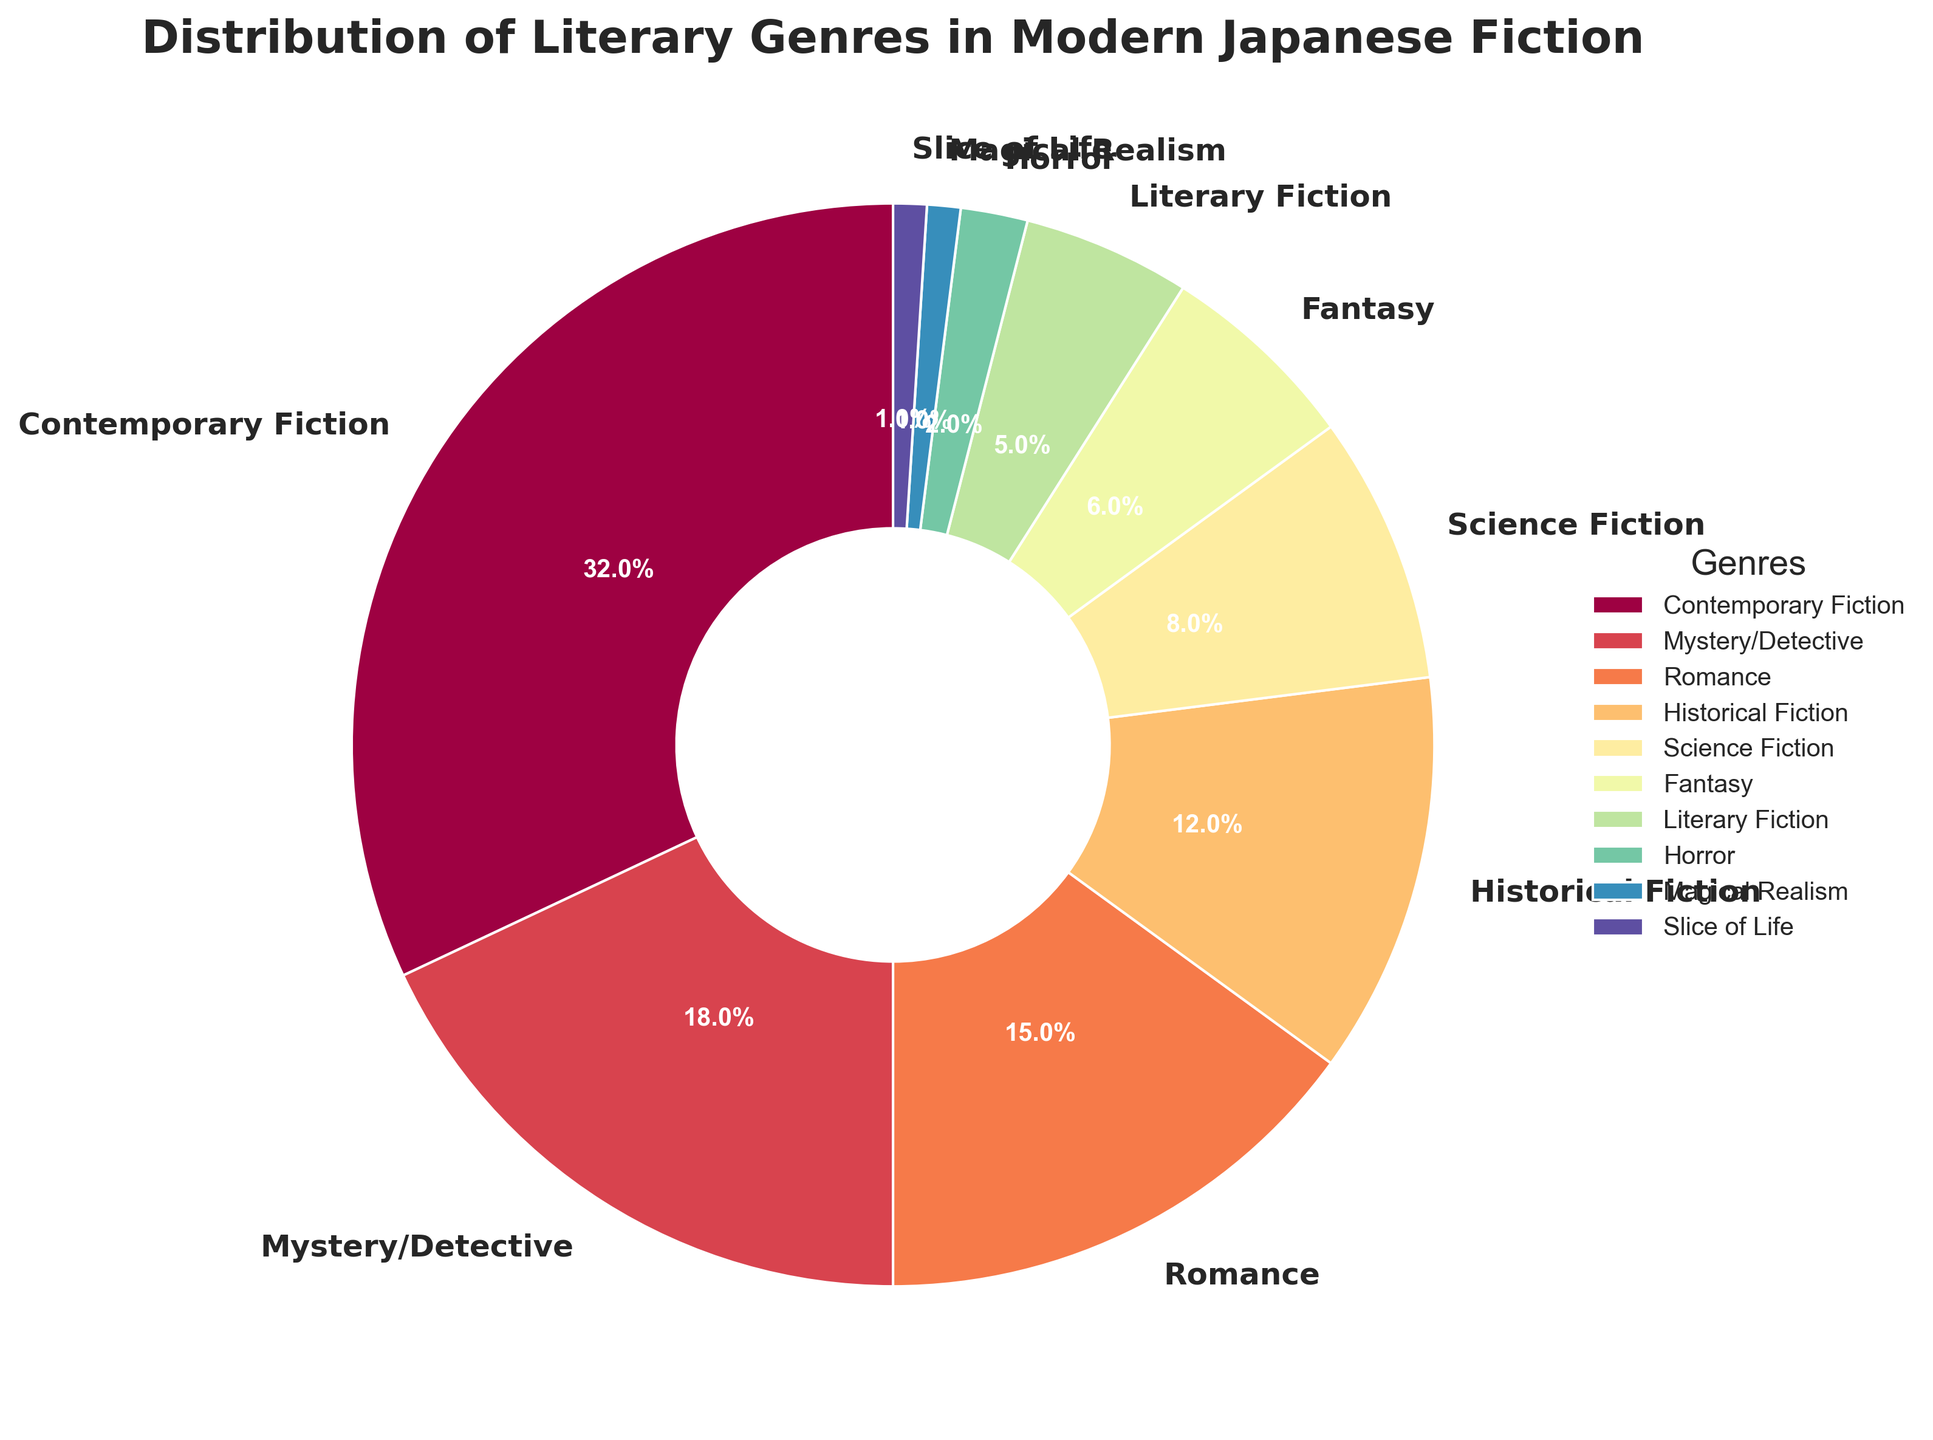Which genre has the highest percentage of distribution in modern Japanese fiction? From the pie chart, Contemporary Fiction occupies the largest segment, which corresponds to 32%.
Answer: Contemporary Fiction Which two genres combined represent less than 10% of the total distribution? The genres with the smallest percentages are Magical Realism at 1% and Slice of Life at 1%. Combined, they represent 1% + 1% = 2%, which is less than 10%.
Answer: Magical Realism and Slice of Life How many genres have a percentage greater than or equal to 15%? The genres with greater than or equal to 15% are Contemporary Fiction (32%), Mystery/Detective (18%), and Romance (15%). There are three such genres.
Answer: 3 What is the difference in percentage between the highest and the lowest genres? The highest percentage is 32% (Contemporary Fiction), and the lowest percentage is 1% (Magical Realism and Slice of Life). The difference is 32% - 1% = 31%.
Answer: 31% Which genre is depicted immediately following the largest segment in a clockwise direction? The largest segment, Contemporary Fiction, is followed by Mystery/Detective which is the next largest segment in the clockwise direction.
Answer: Mystery/Detective If Historical Fiction and Science Fiction were combined, what would the combined percentage be? Historical Fiction has 12%, and Science Fiction has 8%. Their combined percentage would be 12% + 8% = 20%.
Answer: 20% Are there more genres with a percentage below 10% or above 10%? Genres below 10% are Science Fiction (8%), Fantasy (6%), Literary Fiction (5%), Horror (2%), Magical Realism (1%), and Slice of Life (1%) — totaling 6 genres. Genres above 10% are Contemporary Fiction (32%), Mystery/Detective (18%), Romance (15%), and Historical Fiction (12%) — totaling 4 genres. There are more genres with a percentage below 10%.
Answer: Below 10% Which genre is represented with the darkest color in the pie chart? The color scheme uses a gradient from light to dark. Contemporary Fiction has the largest percentage (32%) and is represented with the darkest color.
Answer: Contemporary Fiction What is the sum of the percentages of the three smallest genres? The three smallest genres are Magical Realism (1%), Slice of Life (1%), and Horror (2%). The sum is 1% + 1% + 2% = 4%.
Answer: 4% Which genre has a wedge thickness that matches its percentage closely to its visual representation size? The wedge thickness corresponds well to Contemporary Fiction as it is the largest segment at 32%, matching the visual dominance it commands in the pie chart.
Answer: Contemporary Fiction 